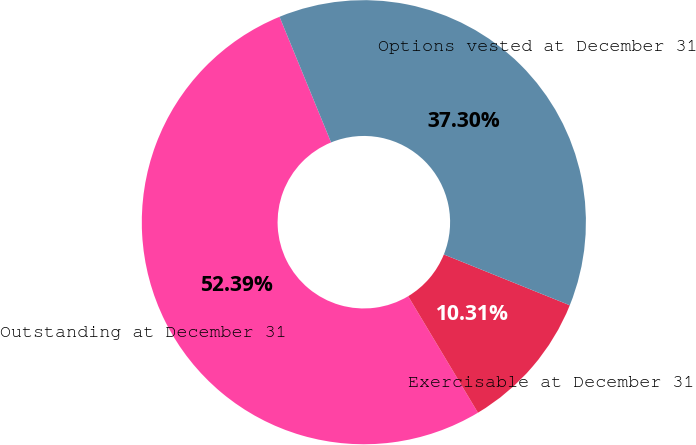<chart> <loc_0><loc_0><loc_500><loc_500><pie_chart><fcel>Outstanding at December 31<fcel>Exercisable at December 31<fcel>Options vested at December 31<nl><fcel>52.39%<fcel>10.31%<fcel>37.3%<nl></chart> 